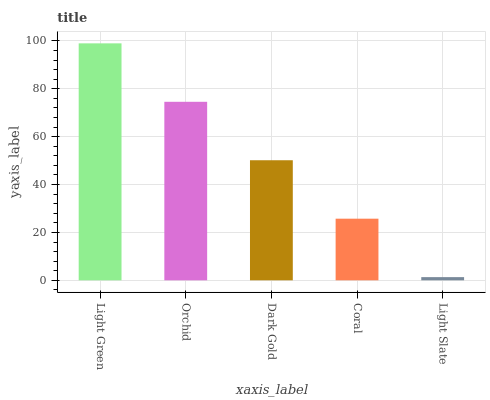Is Light Slate the minimum?
Answer yes or no. Yes. Is Light Green the maximum?
Answer yes or no. Yes. Is Orchid the minimum?
Answer yes or no. No. Is Orchid the maximum?
Answer yes or no. No. Is Light Green greater than Orchid?
Answer yes or no. Yes. Is Orchid less than Light Green?
Answer yes or no. Yes. Is Orchid greater than Light Green?
Answer yes or no. No. Is Light Green less than Orchid?
Answer yes or no. No. Is Dark Gold the high median?
Answer yes or no. Yes. Is Dark Gold the low median?
Answer yes or no. Yes. Is Light Green the high median?
Answer yes or no. No. Is Coral the low median?
Answer yes or no. No. 